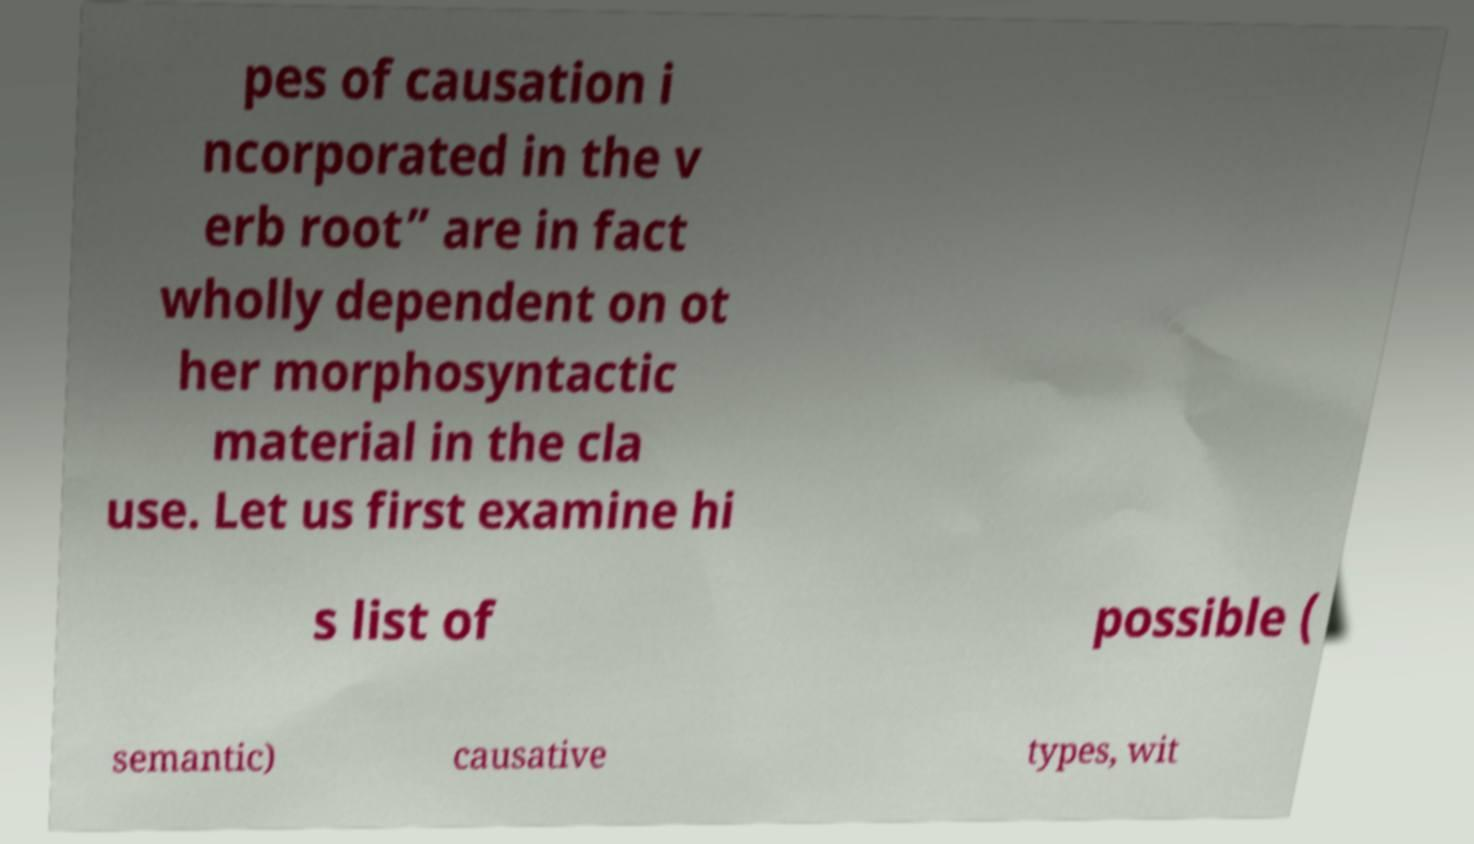Could you assist in decoding the text presented in this image and type it out clearly? pes of causation i ncorporated in the v erb root” are in fact wholly dependent on ot her morphosyntactic material in the cla use. Let us first examine hi s list of possible ( semantic) causative types, wit 